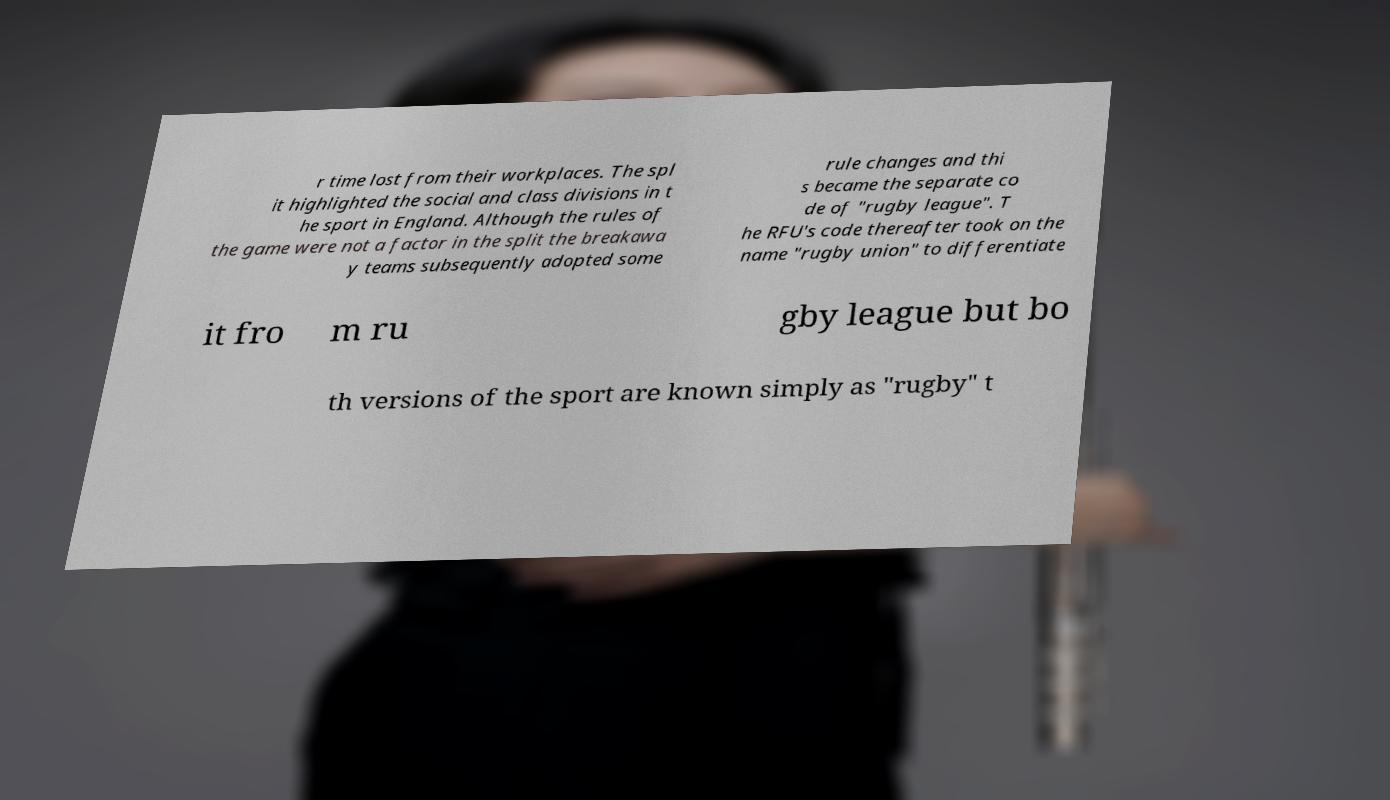For documentation purposes, I need the text within this image transcribed. Could you provide that? r time lost from their workplaces. The spl it highlighted the social and class divisions in t he sport in England. Although the rules of the game were not a factor in the split the breakawa y teams subsequently adopted some rule changes and thi s became the separate co de of "rugby league". T he RFU's code thereafter took on the name "rugby union" to differentiate it fro m ru gby league but bo th versions of the sport are known simply as "rugby" t 